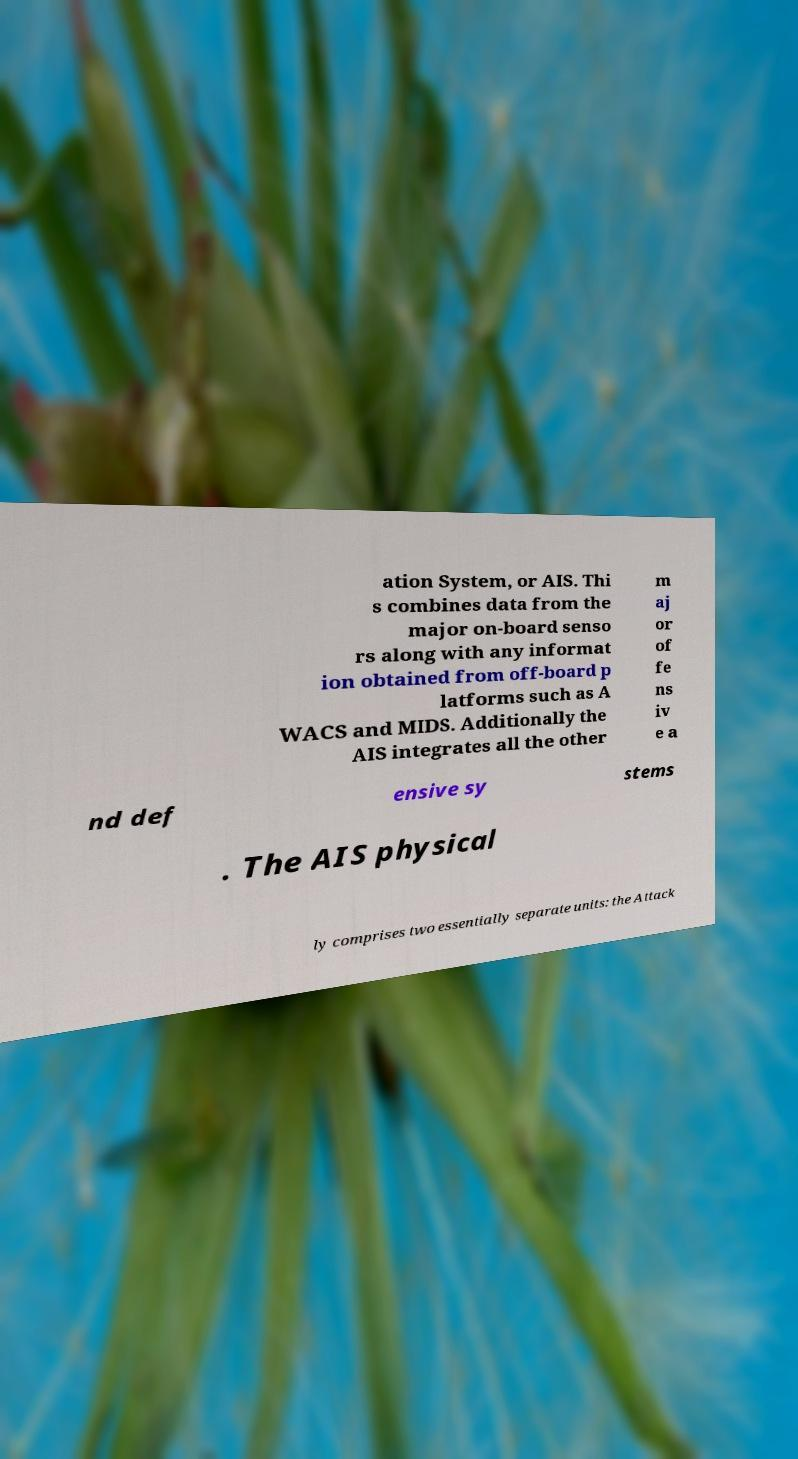There's text embedded in this image that I need extracted. Can you transcribe it verbatim? ation System, or AIS. Thi s combines data from the major on-board senso rs along with any informat ion obtained from off-board p latforms such as A WACS and MIDS. Additionally the AIS integrates all the other m aj or of fe ns iv e a nd def ensive sy stems . The AIS physical ly comprises two essentially separate units: the Attack 